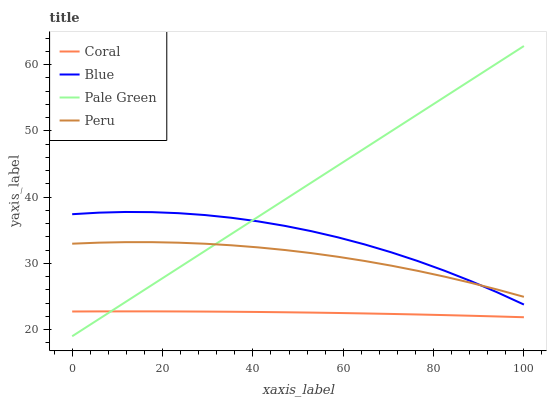Does Coral have the minimum area under the curve?
Answer yes or no. Yes. Does Pale Green have the maximum area under the curve?
Answer yes or no. Yes. Does Pale Green have the minimum area under the curve?
Answer yes or no. No. Does Coral have the maximum area under the curve?
Answer yes or no. No. Is Pale Green the smoothest?
Answer yes or no. Yes. Is Blue the roughest?
Answer yes or no. Yes. Is Coral the smoothest?
Answer yes or no. No. Is Coral the roughest?
Answer yes or no. No. Does Pale Green have the lowest value?
Answer yes or no. Yes. Does Coral have the lowest value?
Answer yes or no. No. Does Pale Green have the highest value?
Answer yes or no. Yes. Does Coral have the highest value?
Answer yes or no. No. Is Coral less than Peru?
Answer yes or no. Yes. Is Peru greater than Coral?
Answer yes or no. Yes. Does Peru intersect Blue?
Answer yes or no. Yes. Is Peru less than Blue?
Answer yes or no. No. Is Peru greater than Blue?
Answer yes or no. No. Does Coral intersect Peru?
Answer yes or no. No. 